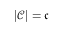Convert formula to latex. <formula><loc_0><loc_0><loc_500><loc_500>| { \mathcal { C } } | = { \mathfrak { c } }</formula> 